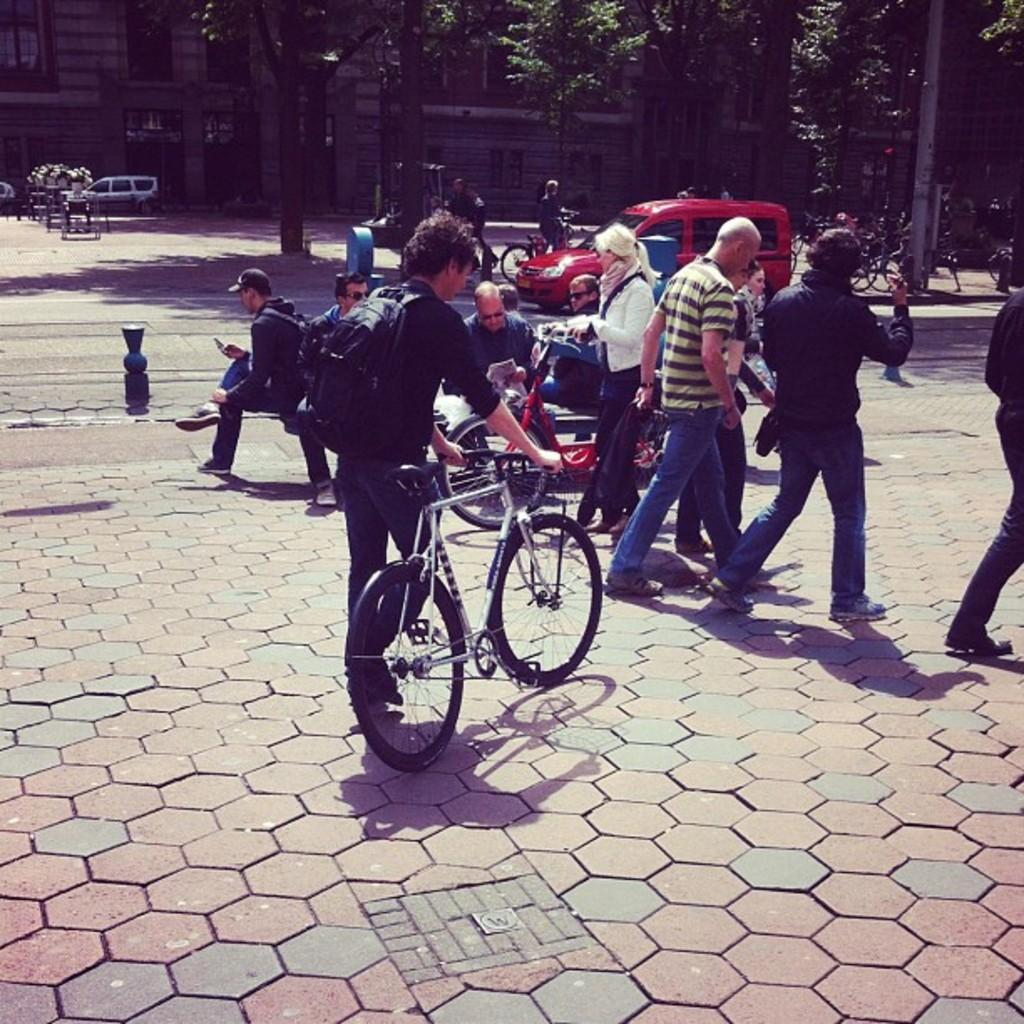Who or what can be seen in the image? There are people in the image. What are the people using in the image? There are bicycles in the image, which suggests that the people are using them. What else is present in the image besides people and bicycles? There are vehicles in the image. Can you describe the setting of the image? The image shows a road, and there are buildings and trees in the background. Are there any other objects visible in the background? Yes, there are some unspecified objects in the background of the image. What type of string is being used to tie the waste to the bikes in the image? There is no string or waste present in the image; it only shows people, bicycles, vehicles, a road, buildings, trees, and unspecified objects in the background. 